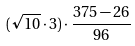Convert formula to latex. <formula><loc_0><loc_0><loc_500><loc_500>( \sqrt { 1 0 } \cdot 3 ) \cdot \frac { 3 7 5 - 2 6 } { 9 6 }</formula> 